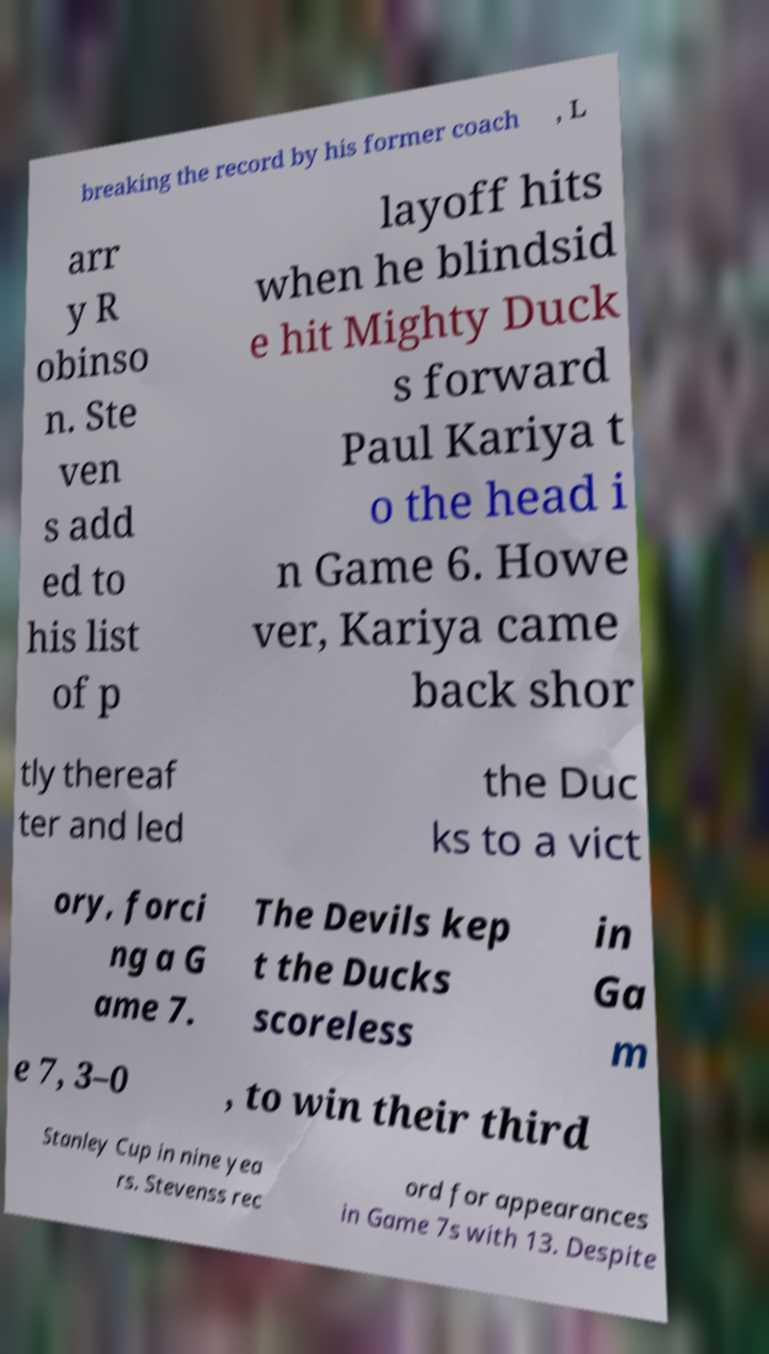Please identify and transcribe the text found in this image. breaking the record by his former coach , L arr y R obinso n. Ste ven s add ed to his list of p layoff hits when he blindsid e hit Mighty Duck s forward Paul Kariya t o the head i n Game 6. Howe ver, Kariya came back shor tly thereaf ter and led the Duc ks to a vict ory, forci ng a G ame 7. The Devils kep t the Ducks scoreless in Ga m e 7, 3–0 , to win their third Stanley Cup in nine yea rs. Stevenss rec ord for appearances in Game 7s with 13. Despite 